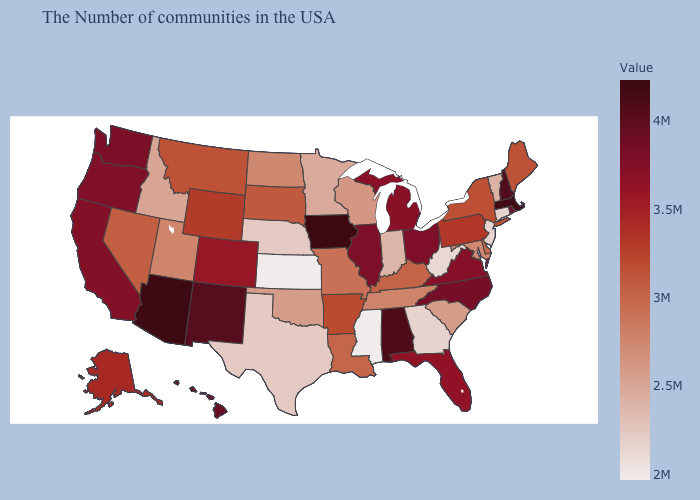Which states have the lowest value in the South?
Short answer required. Mississippi. Among the states that border New York , does Massachusetts have the highest value?
Give a very brief answer. Yes. Is the legend a continuous bar?
Short answer required. Yes. Which states have the lowest value in the Northeast?
Short answer required. New Jersey. 